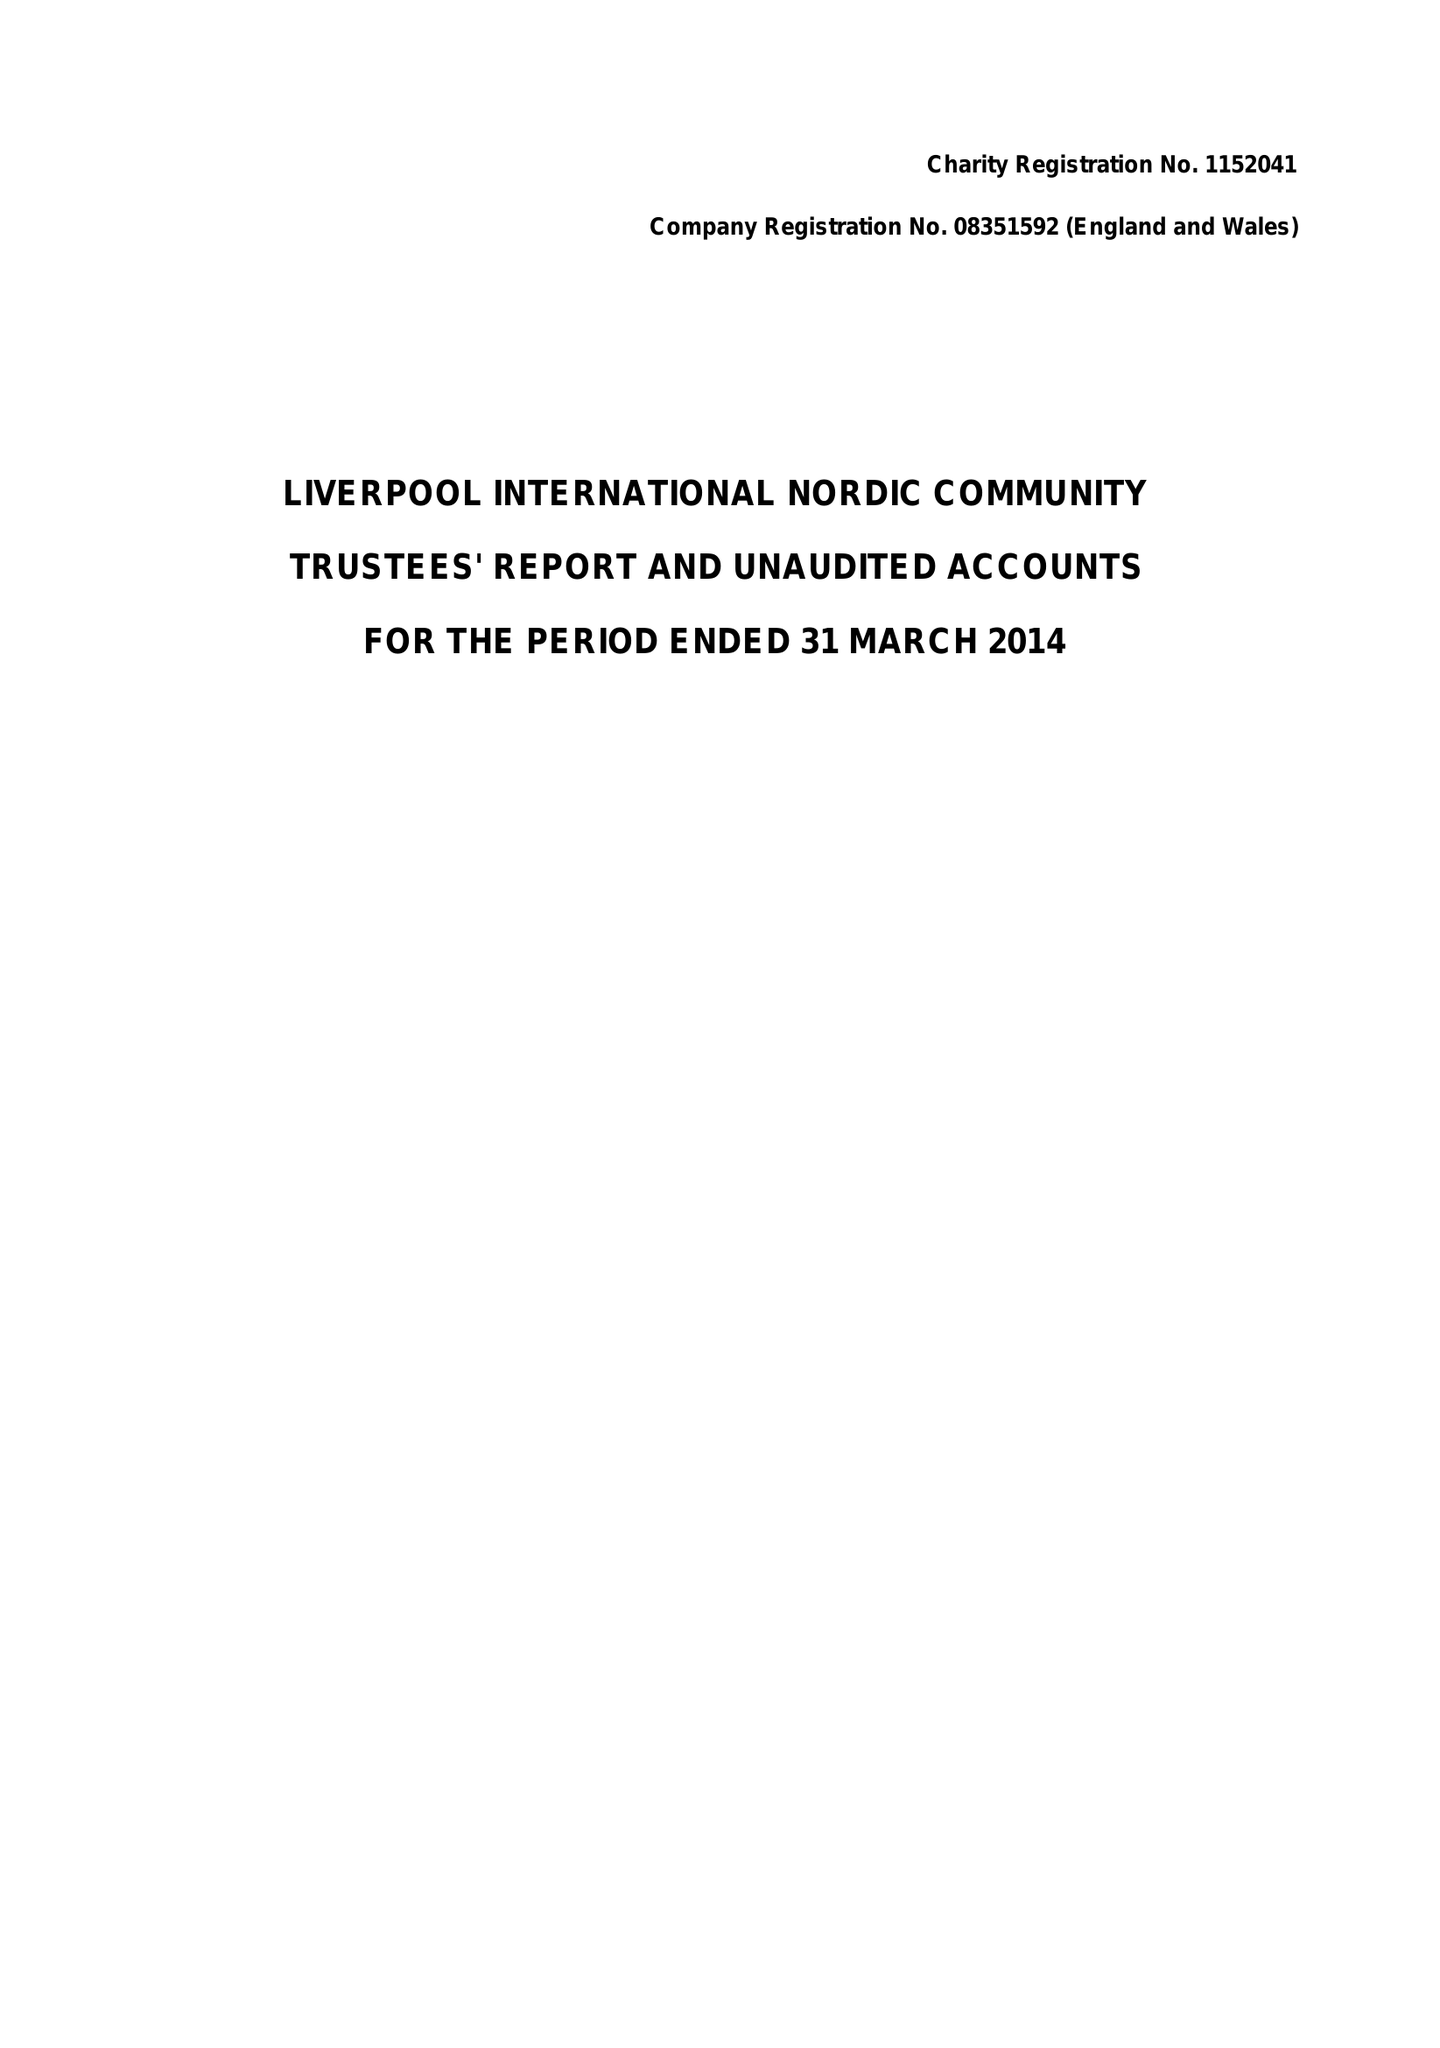What is the value for the address__post_town?
Answer the question using a single word or phrase. LIVERPOOL 